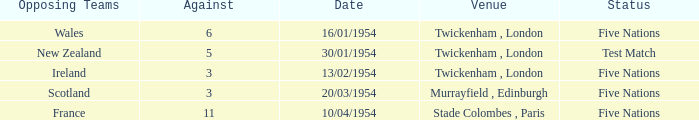What was the venue for the game played on 13/02/1954? Twickenham , London. 